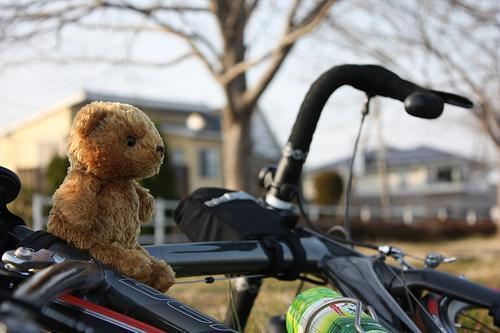How many bears are in the picture?
Give a very brief answer. 1. How many stuffed elephants are sitting on a bicycle?
Give a very brief answer. 0. 